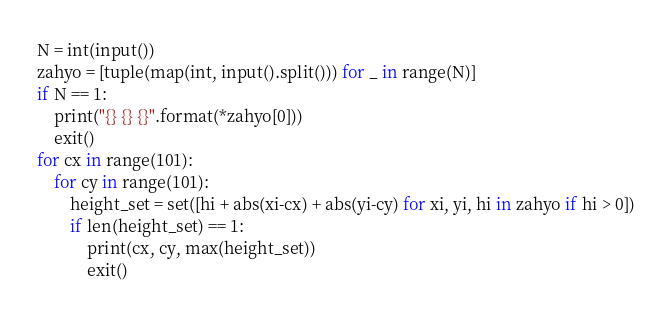Convert code to text. <code><loc_0><loc_0><loc_500><loc_500><_Python_>N = int(input())
zahyo = [tuple(map(int, input().split())) for _ in range(N)]
if N == 1:
    print("{} {} {}".format(*zahyo[0]))
    exit()
for cx in range(101):
    for cy in range(101):
        height_set = set([hi + abs(xi-cx) + abs(yi-cy) for xi, yi, hi in zahyo if hi > 0])
        if len(height_set) == 1:
            print(cx, cy, max(height_set))
            exit()</code> 